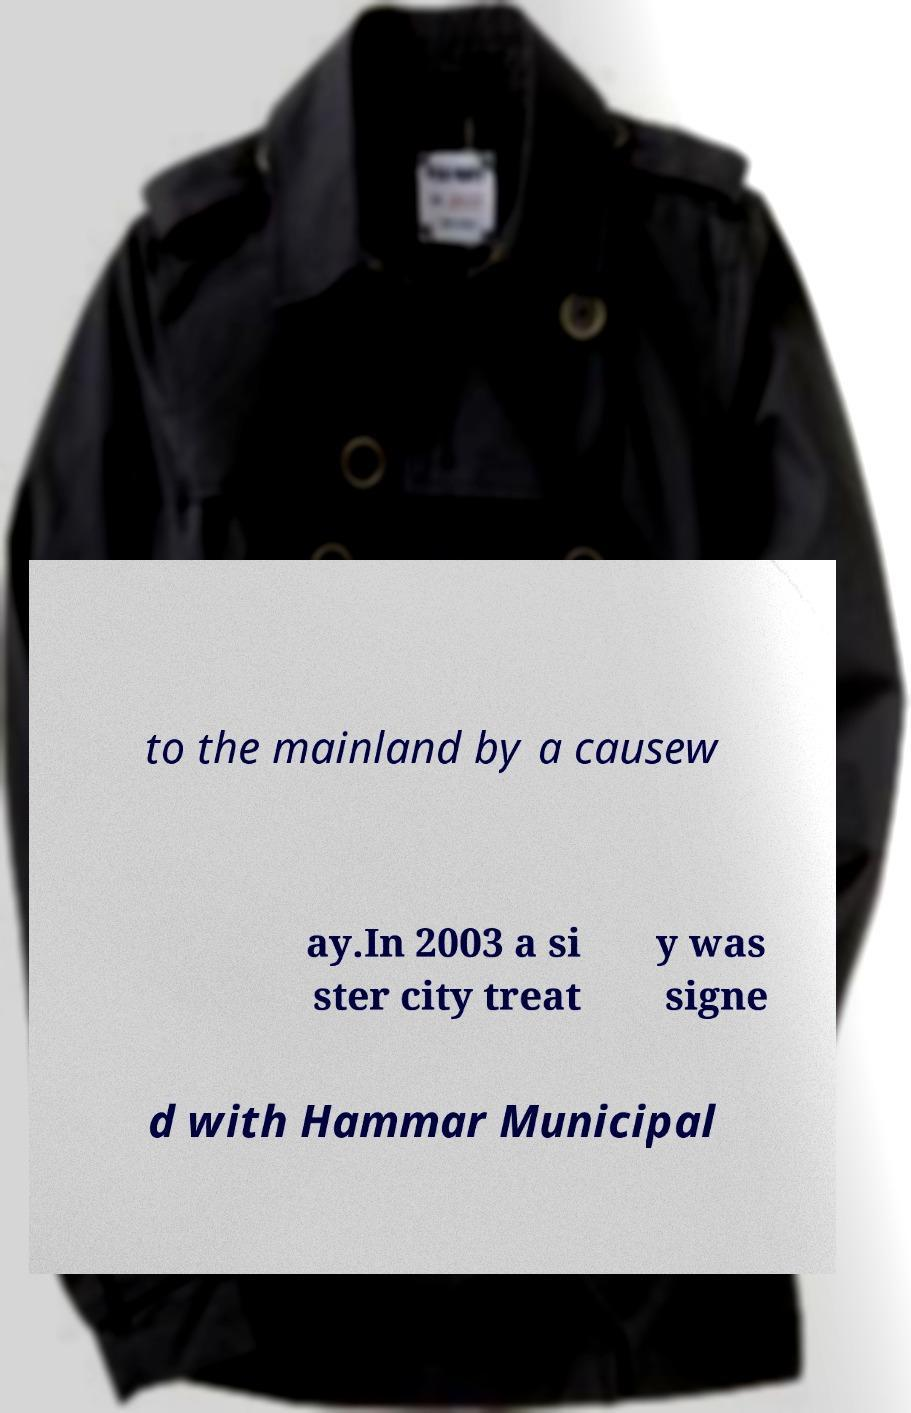There's text embedded in this image that I need extracted. Can you transcribe it verbatim? to the mainland by a causew ay.In 2003 a si ster city treat y was signe d with Hammar Municipal 